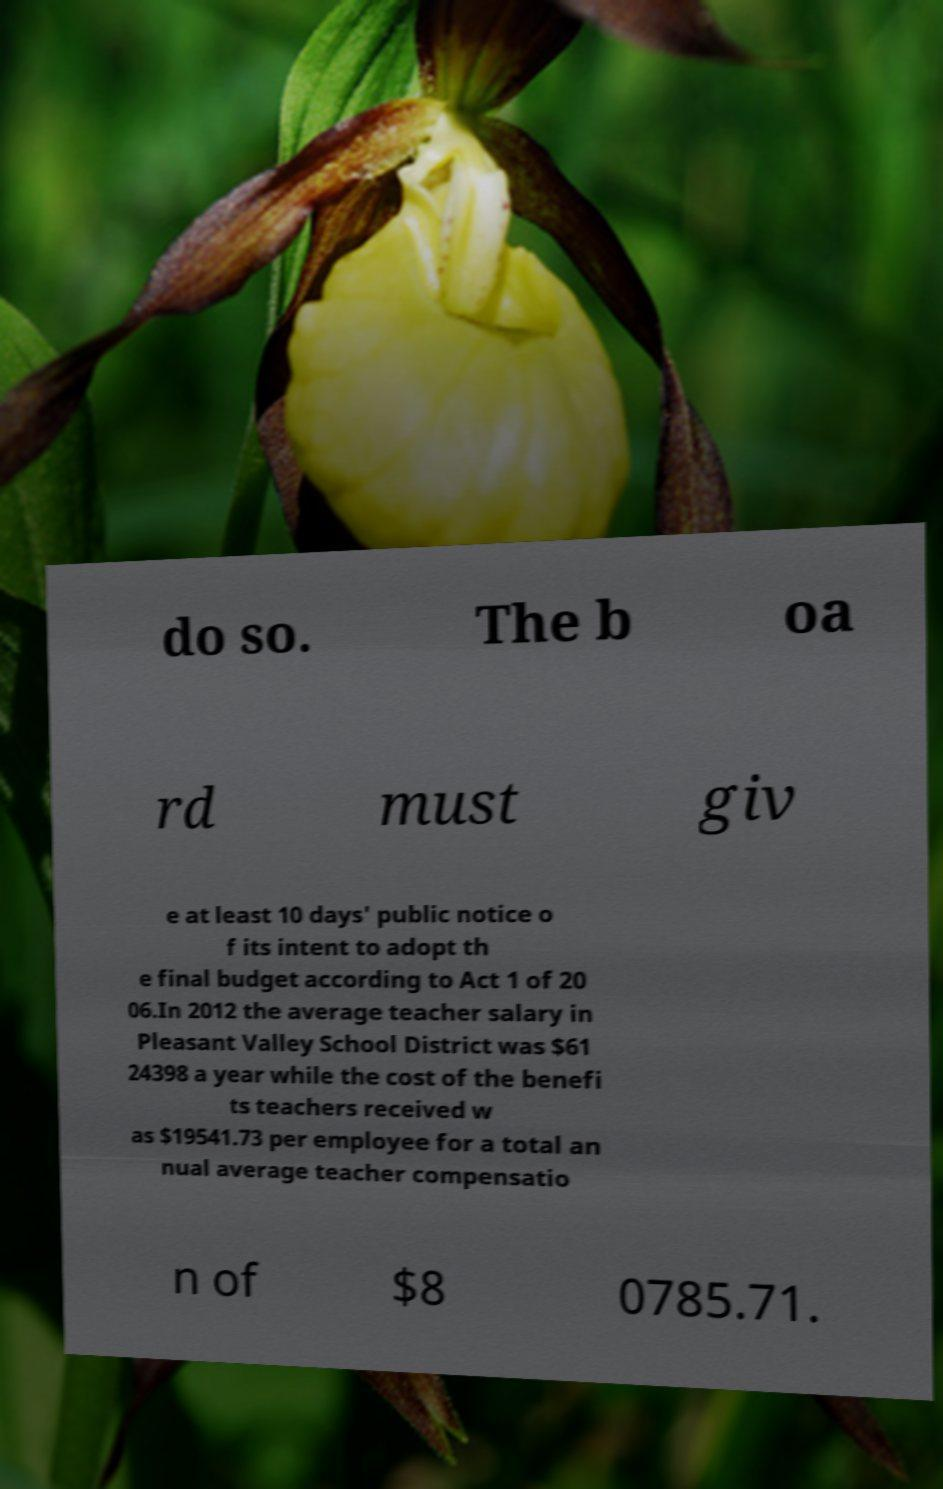Please identify and transcribe the text found in this image. do so. The b oa rd must giv e at least 10 days' public notice o f its intent to adopt th e final budget according to Act 1 of 20 06.In 2012 the average teacher salary in Pleasant Valley School District was $61 24398 a year while the cost of the benefi ts teachers received w as $19541.73 per employee for a total an nual average teacher compensatio n of $8 0785.71. 